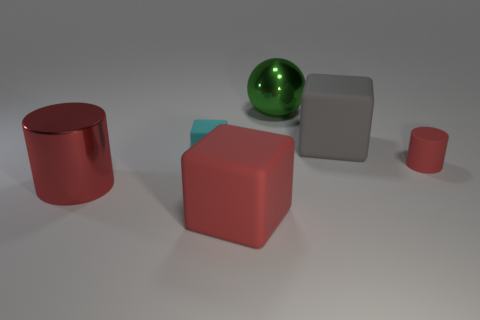Subtract all red rubber blocks. How many blocks are left? 2 Subtract all cyan cubes. How many cubes are left? 2 Add 3 blue cylinders. How many objects exist? 9 Subtract all cylinders. How many objects are left? 4 Subtract 1 cylinders. How many cylinders are left? 1 Add 2 large gray rubber cubes. How many large gray rubber cubes exist? 3 Subtract 1 red cubes. How many objects are left? 5 Subtract all purple blocks. Subtract all gray spheres. How many blocks are left? 3 Subtract all brown cylinders. How many cyan cubes are left? 1 Subtract all red metal cylinders. Subtract all big things. How many objects are left? 1 